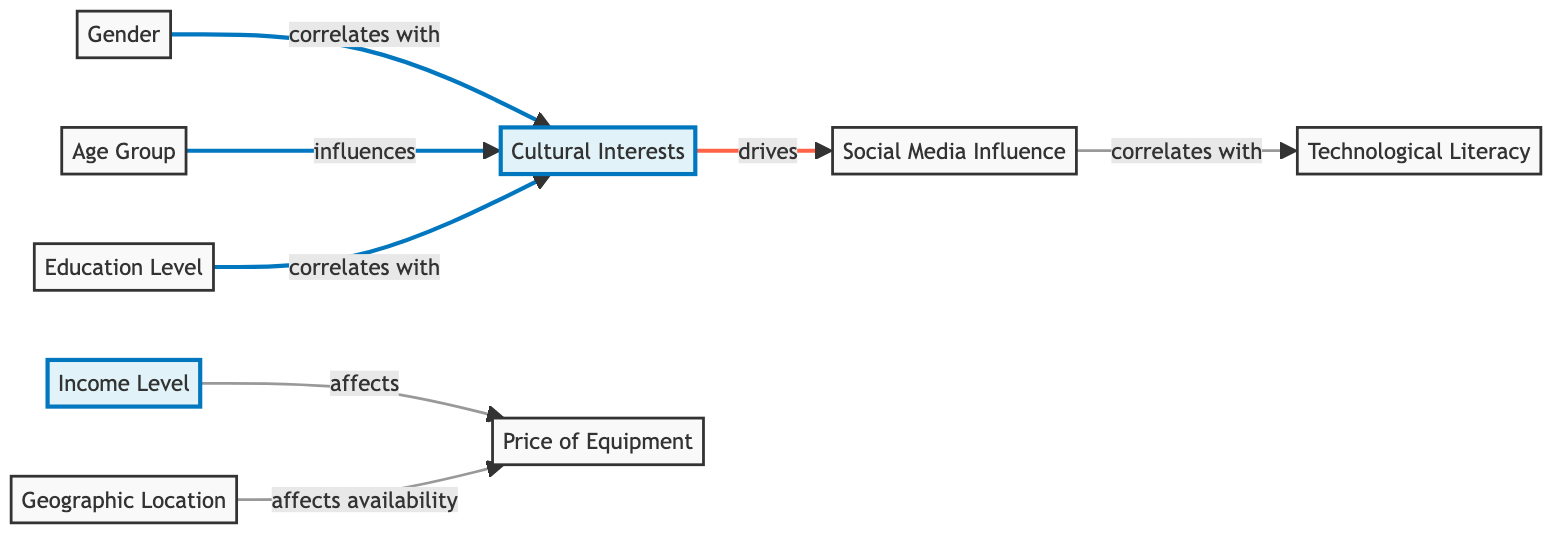What node is influenced by the Age Group? The Age Group node points to Cultural Interests showing that it influences this factor. Therefore, Cultural Interests is influenced by the Age Group.
Answer: Cultural Interests Which node is directly affected by the Income Level? The Income Level node has a direct link that affects the Price of Equipment. Therefore, the Price of Equipment is directly affected by the Income Level.
Answer: Price of Equipment How many nodes are highlighted in the diagram? There are two highlighted nodes, which are Income Level and Cultural Interests.
Answer: Two What is the relationship between Social Media Influence and Technological Literacy? Social Media Influence correlates with Technological Literacy, indicating that changes in Social Media Influence can reflect similar changes in Technological Literacy.
Answer: Correlates Which factor drives Social Media Influence? Cultural Interests drives Social Media Influence, as indicated by the directed arrow from Cultural Interests to Social Media Influence.
Answer: Cultural Interests What demographic factor correlates with Education Level? Gender and Education Level correlate with Cultural Interests as both influence it, but the question specifies a correlation directly mentioned in the diagram.
Answer: Cultural Interests Which node affects the availability of Price of Equipment? The Geographic Location affects the availability of Price of Equipment, as illustrated by the directed arrow from Geographic Location to Price of Equipment.
Answer: Geographic Location Which demographic factors influence Cultural Interests? Age Group, Gender, and Education Level all influence Cultural Interests as indicated by the connections from these nodes.
Answer: Age Group, Gender, Education Level Which nodes are linked without a directional influence in the diagram? There are no nodes linked without a directional influence as all connections show an impact in one direction. Therefore, all are one-directional influences.
Answer: None 